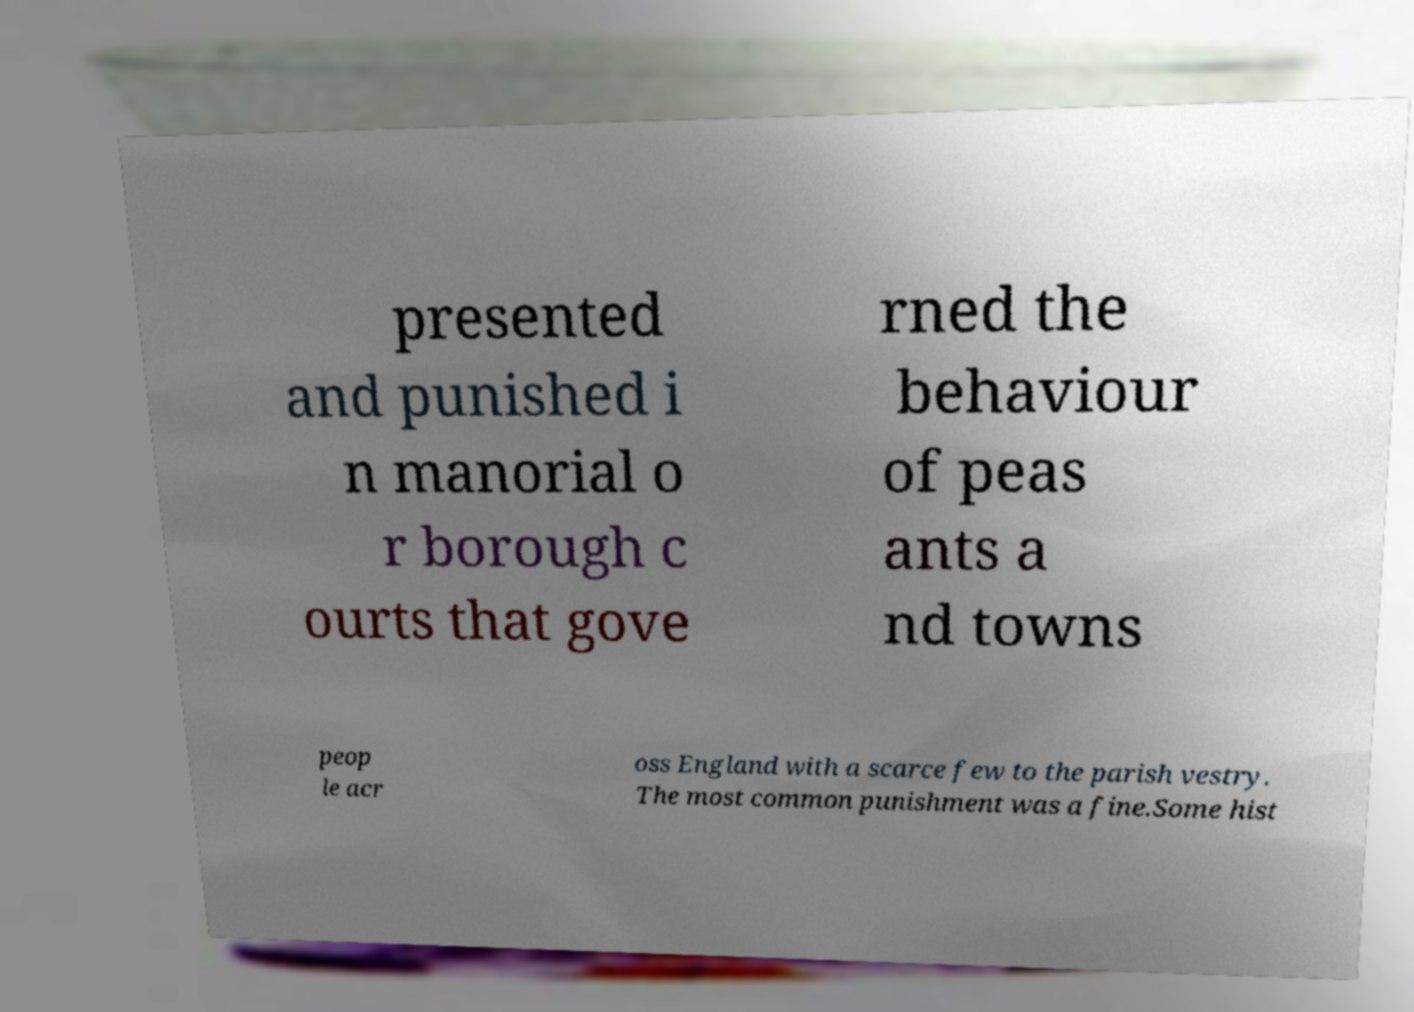Could you assist in decoding the text presented in this image and type it out clearly? presented and punished i n manorial o r borough c ourts that gove rned the behaviour of peas ants a nd towns peop le acr oss England with a scarce few to the parish vestry. The most common punishment was a fine.Some hist 